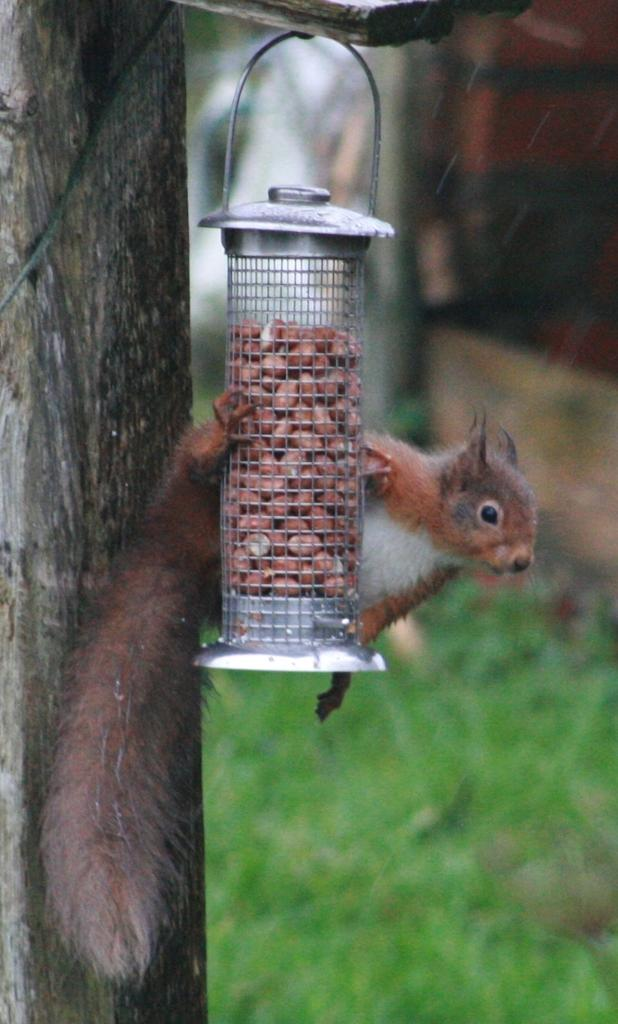What is located in the foreground of the picture? There are nuts, a squirrel, a box, and a tree trunk in the foreground of the picture. Can you describe the main subject in the foreground? The main subject in the foreground is a squirrel. What is the condition of the background in the image? The background of the image is blurred. What can be seen in the background of the picture? There are buildings and grass in the background of the picture. Where is the vase located in the image? There is no vase present in the image. What type of downtown area can be seen in the image? There is no downtown area depicted in the image. 